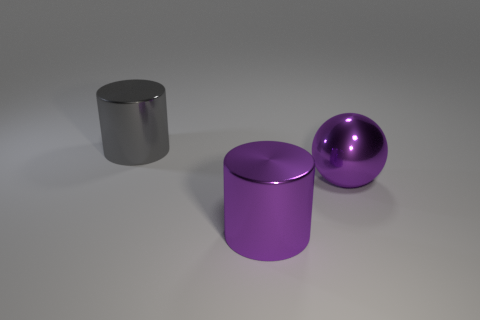How many other objects are the same color as the large metal ball?
Your response must be concise. 1. Is there any other thing that is the same shape as the big gray metal object?
Ensure brevity in your answer.  Yes. What shape is the metallic thing that is behind the big sphere?
Offer a very short reply. Cylinder. How many other big gray metal things are the same shape as the gray thing?
Provide a short and direct response. 0. There is a big metallic cylinder on the right side of the large gray object; does it have the same color as the big sphere that is to the right of the gray shiny cylinder?
Offer a very short reply. Yes. How many things are big gray metal things or large balls?
Offer a terse response. 2. How many big cylinders are the same material as the big purple sphere?
Your answer should be compact. 2. Are there fewer large purple metallic objects than large yellow blocks?
Keep it short and to the point. No. What number of cylinders are either blue metal things or gray metal objects?
Keep it short and to the point. 1. The object that is both left of the sphere and to the right of the large gray metal cylinder has what shape?
Make the answer very short. Cylinder. 